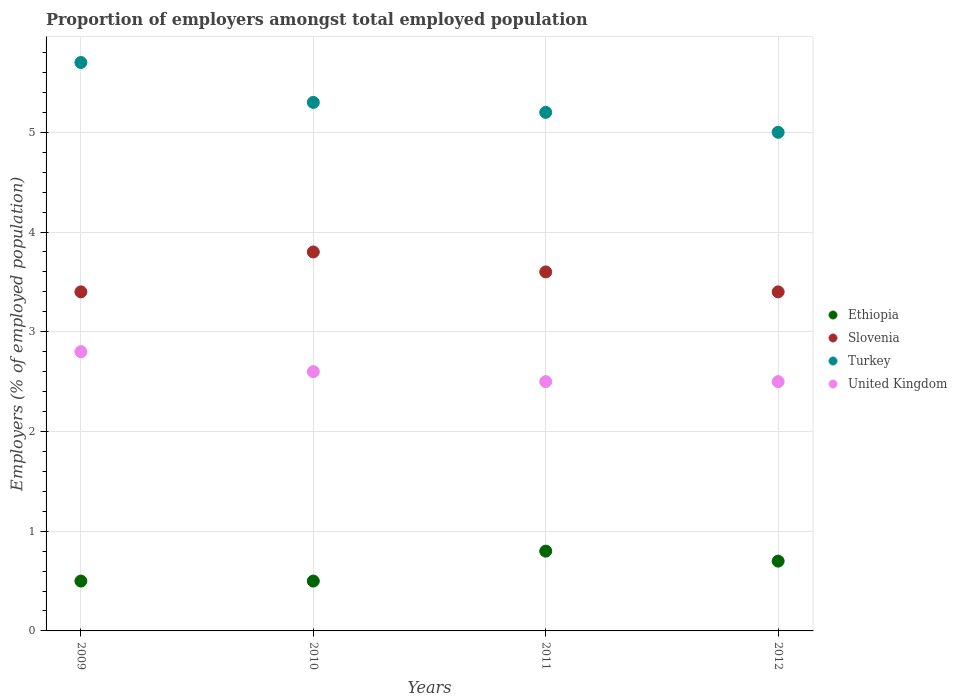Is the number of dotlines equal to the number of legend labels?
Your response must be concise. Yes. Across all years, what is the maximum proportion of employers in Turkey?
Ensure brevity in your answer.  5.7. Across all years, what is the minimum proportion of employers in Slovenia?
Make the answer very short. 3.4. In which year was the proportion of employers in Ethiopia minimum?
Keep it short and to the point. 2009. What is the total proportion of employers in Slovenia in the graph?
Your answer should be compact. 14.2. What is the difference between the proportion of employers in Ethiopia in 2011 and that in 2012?
Make the answer very short. 0.1. What is the difference between the proportion of employers in Ethiopia in 2011 and the proportion of employers in United Kingdom in 2009?
Your answer should be compact. -2. What is the average proportion of employers in Turkey per year?
Make the answer very short. 5.3. In the year 2010, what is the difference between the proportion of employers in Slovenia and proportion of employers in Turkey?
Your answer should be compact. -1.5. What is the ratio of the proportion of employers in Slovenia in 2009 to that in 2010?
Provide a succinct answer. 0.89. Is the proportion of employers in Turkey in 2010 less than that in 2012?
Give a very brief answer. No. What is the difference between the highest and the second highest proportion of employers in Turkey?
Give a very brief answer. 0.4. What is the difference between the highest and the lowest proportion of employers in Ethiopia?
Your answer should be compact. 0.3. In how many years, is the proportion of employers in Slovenia greater than the average proportion of employers in Slovenia taken over all years?
Offer a very short reply. 2. Is the sum of the proportion of employers in Ethiopia in 2010 and 2012 greater than the maximum proportion of employers in Turkey across all years?
Provide a succinct answer. No. Is it the case that in every year, the sum of the proportion of employers in Slovenia and proportion of employers in Turkey  is greater than the sum of proportion of employers in United Kingdom and proportion of employers in Ethiopia?
Your response must be concise. No. Does the proportion of employers in Turkey monotonically increase over the years?
Your response must be concise. No. How many years are there in the graph?
Your answer should be very brief. 4. Are the values on the major ticks of Y-axis written in scientific E-notation?
Give a very brief answer. No. Does the graph contain any zero values?
Keep it short and to the point. No. Where does the legend appear in the graph?
Your response must be concise. Center right. What is the title of the graph?
Provide a short and direct response. Proportion of employers amongst total employed population. Does "Timor-Leste" appear as one of the legend labels in the graph?
Keep it short and to the point. No. What is the label or title of the Y-axis?
Provide a succinct answer. Employers (% of employed population). What is the Employers (% of employed population) of Slovenia in 2009?
Provide a succinct answer. 3.4. What is the Employers (% of employed population) in Turkey in 2009?
Ensure brevity in your answer.  5.7. What is the Employers (% of employed population) of United Kingdom in 2009?
Keep it short and to the point. 2.8. What is the Employers (% of employed population) of Ethiopia in 2010?
Your answer should be very brief. 0.5. What is the Employers (% of employed population) in Slovenia in 2010?
Provide a succinct answer. 3.8. What is the Employers (% of employed population) of Turkey in 2010?
Your response must be concise. 5.3. What is the Employers (% of employed population) of United Kingdom in 2010?
Your answer should be very brief. 2.6. What is the Employers (% of employed population) in Ethiopia in 2011?
Offer a very short reply. 0.8. What is the Employers (% of employed population) of Slovenia in 2011?
Your response must be concise. 3.6. What is the Employers (% of employed population) in Turkey in 2011?
Your response must be concise. 5.2. What is the Employers (% of employed population) in United Kingdom in 2011?
Your answer should be compact. 2.5. What is the Employers (% of employed population) of Ethiopia in 2012?
Keep it short and to the point. 0.7. What is the Employers (% of employed population) in Slovenia in 2012?
Keep it short and to the point. 3.4. What is the Employers (% of employed population) in Turkey in 2012?
Provide a short and direct response. 5. Across all years, what is the maximum Employers (% of employed population) of Ethiopia?
Your answer should be compact. 0.8. Across all years, what is the maximum Employers (% of employed population) in Slovenia?
Your response must be concise. 3.8. Across all years, what is the maximum Employers (% of employed population) in Turkey?
Make the answer very short. 5.7. Across all years, what is the maximum Employers (% of employed population) of United Kingdom?
Provide a succinct answer. 2.8. Across all years, what is the minimum Employers (% of employed population) in Ethiopia?
Provide a succinct answer. 0.5. Across all years, what is the minimum Employers (% of employed population) in Slovenia?
Provide a succinct answer. 3.4. What is the total Employers (% of employed population) of Turkey in the graph?
Your response must be concise. 21.2. What is the total Employers (% of employed population) in United Kingdom in the graph?
Provide a short and direct response. 10.4. What is the difference between the Employers (% of employed population) in Ethiopia in 2009 and that in 2010?
Your answer should be very brief. 0. What is the difference between the Employers (% of employed population) in Slovenia in 2009 and that in 2010?
Make the answer very short. -0.4. What is the difference between the Employers (% of employed population) of Turkey in 2009 and that in 2010?
Provide a short and direct response. 0.4. What is the difference between the Employers (% of employed population) of United Kingdom in 2009 and that in 2010?
Make the answer very short. 0.2. What is the difference between the Employers (% of employed population) in Slovenia in 2009 and that in 2011?
Keep it short and to the point. -0.2. What is the difference between the Employers (% of employed population) in Turkey in 2009 and that in 2011?
Make the answer very short. 0.5. What is the difference between the Employers (% of employed population) in Ethiopia in 2009 and that in 2012?
Offer a very short reply. -0.2. What is the difference between the Employers (% of employed population) in Turkey in 2009 and that in 2012?
Your answer should be compact. 0.7. What is the difference between the Employers (% of employed population) of Turkey in 2010 and that in 2011?
Provide a short and direct response. 0.1. What is the difference between the Employers (% of employed population) of Ethiopia in 2010 and that in 2012?
Keep it short and to the point. -0.2. What is the difference between the Employers (% of employed population) of Ethiopia in 2011 and that in 2012?
Ensure brevity in your answer.  0.1. What is the difference between the Employers (% of employed population) of United Kingdom in 2011 and that in 2012?
Make the answer very short. 0. What is the difference between the Employers (% of employed population) in Ethiopia in 2009 and the Employers (% of employed population) in Slovenia in 2010?
Provide a short and direct response. -3.3. What is the difference between the Employers (% of employed population) of Ethiopia in 2009 and the Employers (% of employed population) of United Kingdom in 2010?
Your response must be concise. -2.1. What is the difference between the Employers (% of employed population) of Slovenia in 2009 and the Employers (% of employed population) of United Kingdom in 2010?
Keep it short and to the point. 0.8. What is the difference between the Employers (% of employed population) in Turkey in 2009 and the Employers (% of employed population) in United Kingdom in 2010?
Give a very brief answer. 3.1. What is the difference between the Employers (% of employed population) in Ethiopia in 2009 and the Employers (% of employed population) in Turkey in 2011?
Offer a very short reply. -4.7. What is the difference between the Employers (% of employed population) in Ethiopia in 2009 and the Employers (% of employed population) in Slovenia in 2012?
Your answer should be compact. -2.9. What is the difference between the Employers (% of employed population) in Ethiopia in 2009 and the Employers (% of employed population) in United Kingdom in 2012?
Ensure brevity in your answer.  -2. What is the difference between the Employers (% of employed population) of Ethiopia in 2010 and the Employers (% of employed population) of Turkey in 2011?
Your answer should be very brief. -4.7. What is the difference between the Employers (% of employed population) of Ethiopia in 2010 and the Employers (% of employed population) of United Kingdom in 2011?
Offer a terse response. -2. What is the difference between the Employers (% of employed population) of Slovenia in 2010 and the Employers (% of employed population) of United Kingdom in 2011?
Offer a very short reply. 1.3. What is the difference between the Employers (% of employed population) in Turkey in 2010 and the Employers (% of employed population) in United Kingdom in 2011?
Your response must be concise. 2.8. What is the difference between the Employers (% of employed population) of Ethiopia in 2010 and the Employers (% of employed population) of Turkey in 2012?
Keep it short and to the point. -4.5. What is the difference between the Employers (% of employed population) of Ethiopia in 2010 and the Employers (% of employed population) of United Kingdom in 2012?
Offer a terse response. -2. What is the difference between the Employers (% of employed population) of Slovenia in 2010 and the Employers (% of employed population) of Turkey in 2012?
Your response must be concise. -1.2. What is the difference between the Employers (% of employed population) in Ethiopia in 2011 and the Employers (% of employed population) in Slovenia in 2012?
Give a very brief answer. -2.6. What is the difference between the Employers (% of employed population) of Ethiopia in 2011 and the Employers (% of employed population) of Turkey in 2012?
Provide a short and direct response. -4.2. What is the difference between the Employers (% of employed population) in Slovenia in 2011 and the Employers (% of employed population) in Turkey in 2012?
Your answer should be very brief. -1.4. What is the average Employers (% of employed population) of Slovenia per year?
Ensure brevity in your answer.  3.55. What is the average Employers (% of employed population) in Turkey per year?
Offer a very short reply. 5.3. In the year 2009, what is the difference between the Employers (% of employed population) in Ethiopia and Employers (% of employed population) in Slovenia?
Provide a succinct answer. -2.9. In the year 2009, what is the difference between the Employers (% of employed population) of Ethiopia and Employers (% of employed population) of United Kingdom?
Offer a terse response. -2.3. In the year 2009, what is the difference between the Employers (% of employed population) of Slovenia and Employers (% of employed population) of United Kingdom?
Your response must be concise. 0.6. In the year 2009, what is the difference between the Employers (% of employed population) in Turkey and Employers (% of employed population) in United Kingdom?
Give a very brief answer. 2.9. In the year 2010, what is the difference between the Employers (% of employed population) in Ethiopia and Employers (% of employed population) in Slovenia?
Your answer should be compact. -3.3. In the year 2010, what is the difference between the Employers (% of employed population) in Ethiopia and Employers (% of employed population) in United Kingdom?
Make the answer very short. -2.1. In the year 2010, what is the difference between the Employers (% of employed population) of Slovenia and Employers (% of employed population) of United Kingdom?
Offer a terse response. 1.2. In the year 2010, what is the difference between the Employers (% of employed population) of Turkey and Employers (% of employed population) of United Kingdom?
Your answer should be very brief. 2.7. In the year 2011, what is the difference between the Employers (% of employed population) in Ethiopia and Employers (% of employed population) in United Kingdom?
Provide a succinct answer. -1.7. In the year 2011, what is the difference between the Employers (% of employed population) in Slovenia and Employers (% of employed population) in Turkey?
Provide a succinct answer. -1.6. In the year 2011, what is the difference between the Employers (% of employed population) of Slovenia and Employers (% of employed population) of United Kingdom?
Offer a very short reply. 1.1. In the year 2011, what is the difference between the Employers (% of employed population) of Turkey and Employers (% of employed population) of United Kingdom?
Give a very brief answer. 2.7. In the year 2012, what is the difference between the Employers (% of employed population) in Slovenia and Employers (% of employed population) in Turkey?
Your response must be concise. -1.6. In the year 2012, what is the difference between the Employers (% of employed population) of Slovenia and Employers (% of employed population) of United Kingdom?
Ensure brevity in your answer.  0.9. What is the ratio of the Employers (% of employed population) of Slovenia in 2009 to that in 2010?
Your answer should be compact. 0.89. What is the ratio of the Employers (% of employed population) in Turkey in 2009 to that in 2010?
Your answer should be very brief. 1.08. What is the ratio of the Employers (% of employed population) in Ethiopia in 2009 to that in 2011?
Provide a succinct answer. 0.62. What is the ratio of the Employers (% of employed population) in Turkey in 2009 to that in 2011?
Ensure brevity in your answer.  1.1. What is the ratio of the Employers (% of employed population) in United Kingdom in 2009 to that in 2011?
Your answer should be compact. 1.12. What is the ratio of the Employers (% of employed population) in Ethiopia in 2009 to that in 2012?
Keep it short and to the point. 0.71. What is the ratio of the Employers (% of employed population) of Turkey in 2009 to that in 2012?
Your answer should be very brief. 1.14. What is the ratio of the Employers (% of employed population) in United Kingdom in 2009 to that in 2012?
Your response must be concise. 1.12. What is the ratio of the Employers (% of employed population) in Slovenia in 2010 to that in 2011?
Keep it short and to the point. 1.06. What is the ratio of the Employers (% of employed population) of Turkey in 2010 to that in 2011?
Give a very brief answer. 1.02. What is the ratio of the Employers (% of employed population) of United Kingdom in 2010 to that in 2011?
Your response must be concise. 1.04. What is the ratio of the Employers (% of employed population) in Ethiopia in 2010 to that in 2012?
Offer a terse response. 0.71. What is the ratio of the Employers (% of employed population) of Slovenia in 2010 to that in 2012?
Offer a very short reply. 1.12. What is the ratio of the Employers (% of employed population) in Turkey in 2010 to that in 2012?
Your answer should be compact. 1.06. What is the ratio of the Employers (% of employed population) in Slovenia in 2011 to that in 2012?
Your answer should be compact. 1.06. What is the ratio of the Employers (% of employed population) in United Kingdom in 2011 to that in 2012?
Provide a succinct answer. 1. What is the difference between the highest and the second highest Employers (% of employed population) of Slovenia?
Give a very brief answer. 0.2. What is the difference between the highest and the second highest Employers (% of employed population) of Turkey?
Provide a short and direct response. 0.4. What is the difference between the highest and the lowest Employers (% of employed population) in Ethiopia?
Offer a terse response. 0.3. What is the difference between the highest and the lowest Employers (% of employed population) of Turkey?
Provide a succinct answer. 0.7. What is the difference between the highest and the lowest Employers (% of employed population) in United Kingdom?
Provide a short and direct response. 0.3. 